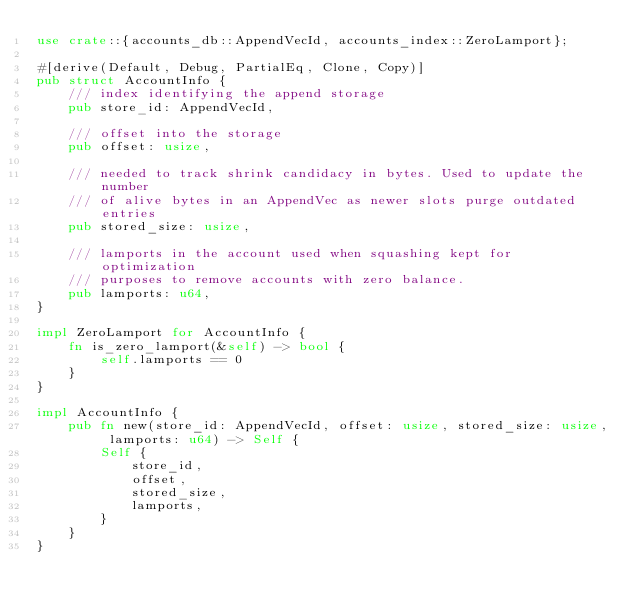Convert code to text. <code><loc_0><loc_0><loc_500><loc_500><_Rust_>use crate::{accounts_db::AppendVecId, accounts_index::ZeroLamport};

#[derive(Default, Debug, PartialEq, Clone, Copy)]
pub struct AccountInfo {
    /// index identifying the append storage
    pub store_id: AppendVecId,

    /// offset into the storage
    pub offset: usize,

    /// needed to track shrink candidacy in bytes. Used to update the number
    /// of alive bytes in an AppendVec as newer slots purge outdated entries
    pub stored_size: usize,

    /// lamports in the account used when squashing kept for optimization
    /// purposes to remove accounts with zero balance.
    pub lamports: u64,
}

impl ZeroLamport for AccountInfo {
    fn is_zero_lamport(&self) -> bool {
        self.lamports == 0
    }
}

impl AccountInfo {
    pub fn new(store_id: AppendVecId, offset: usize, stored_size: usize, lamports: u64) -> Self {
        Self {
            store_id,
            offset,
            stored_size,
            lamports,
        }
    }
}
</code> 